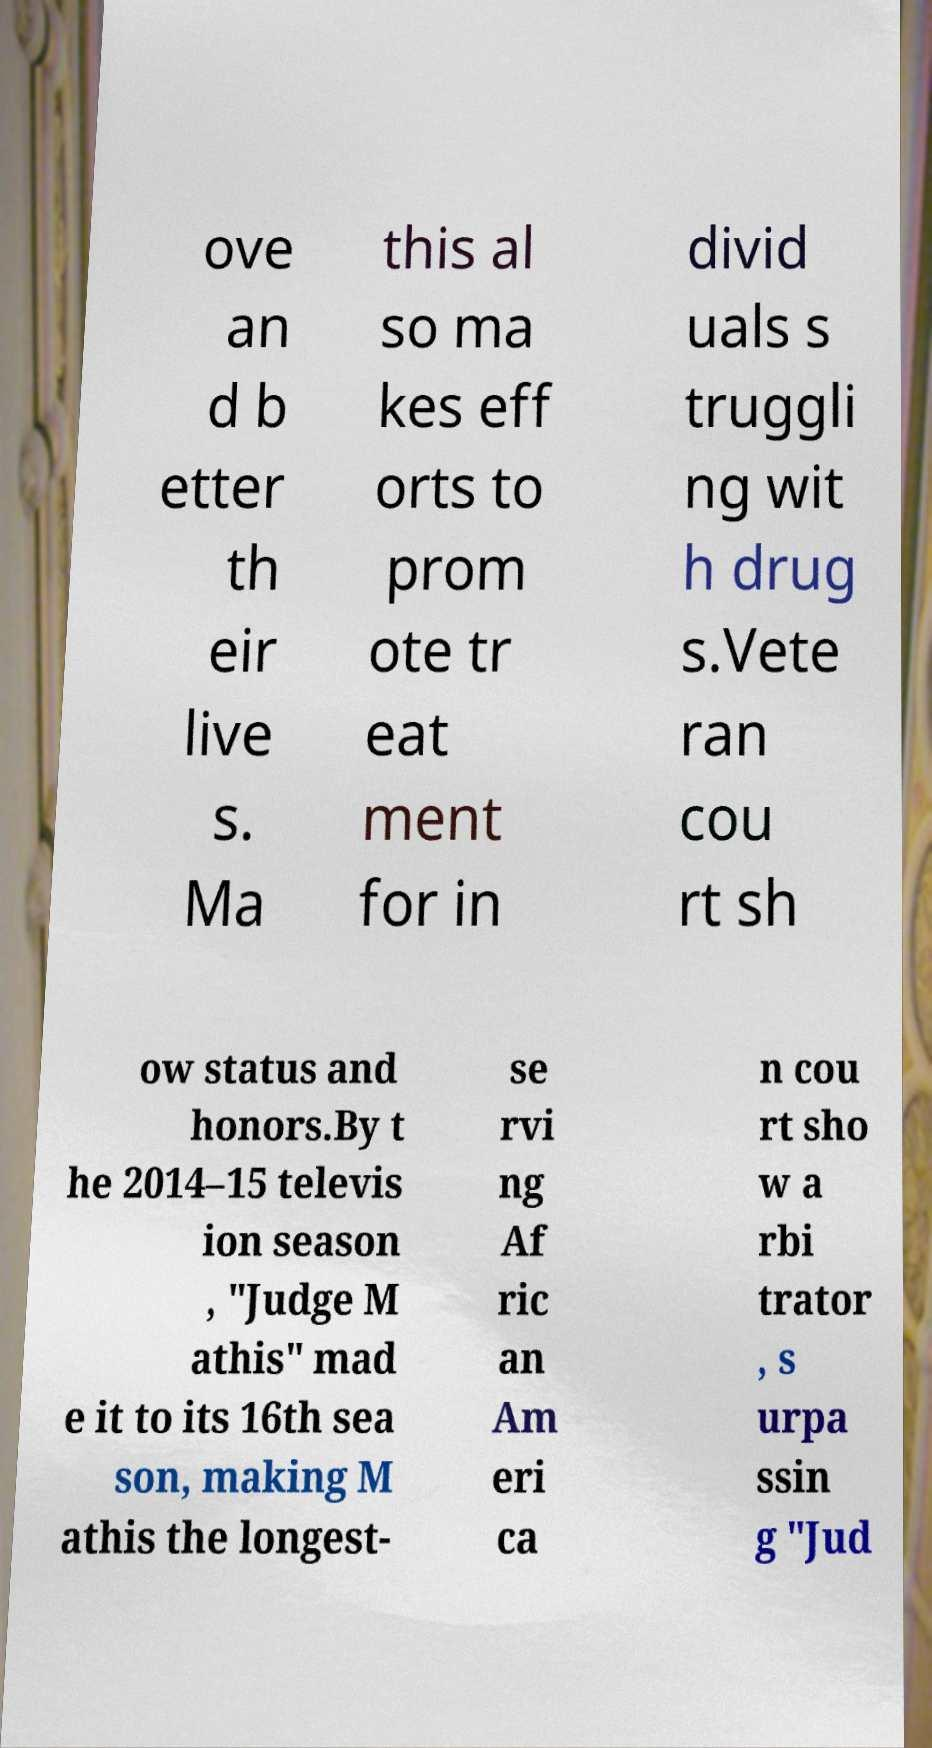What messages or text are displayed in this image? I need them in a readable, typed format. ove an d b etter th eir live s. Ma this al so ma kes eff orts to prom ote tr eat ment for in divid uals s truggli ng wit h drug s.Vete ran cou rt sh ow status and honors.By t he 2014–15 televis ion season , "Judge M athis" mad e it to its 16th sea son, making M athis the longest- se rvi ng Af ric an Am eri ca n cou rt sho w a rbi trator , s urpa ssin g "Jud 